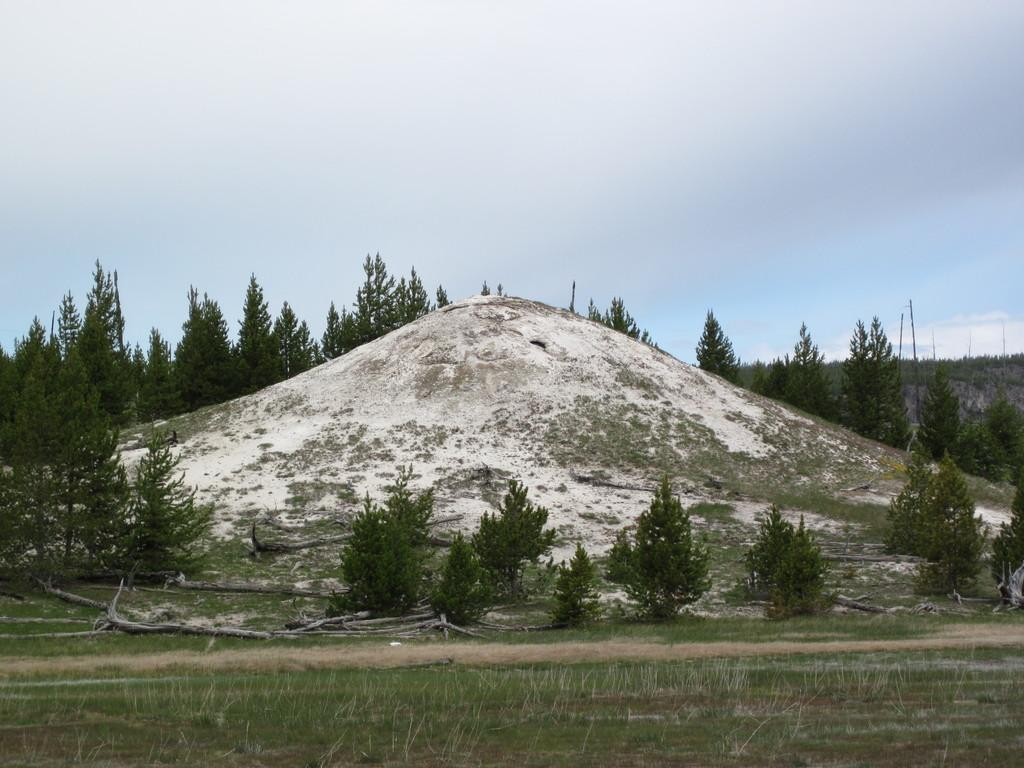What objects are on the ground in the image? There are sticks on the ground in the image. What type of vegetation is on the ground in the image? There is grass on the ground in the image. What can be seen in the background of the image? There are trees and the sky visible in the background of the image. What is the income of the person who owns the tank in the image? There is no tank present in the image, so it is not possible to determine the income of the person who might own one. 